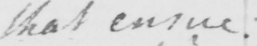What does this handwritten line say? that ensue : 